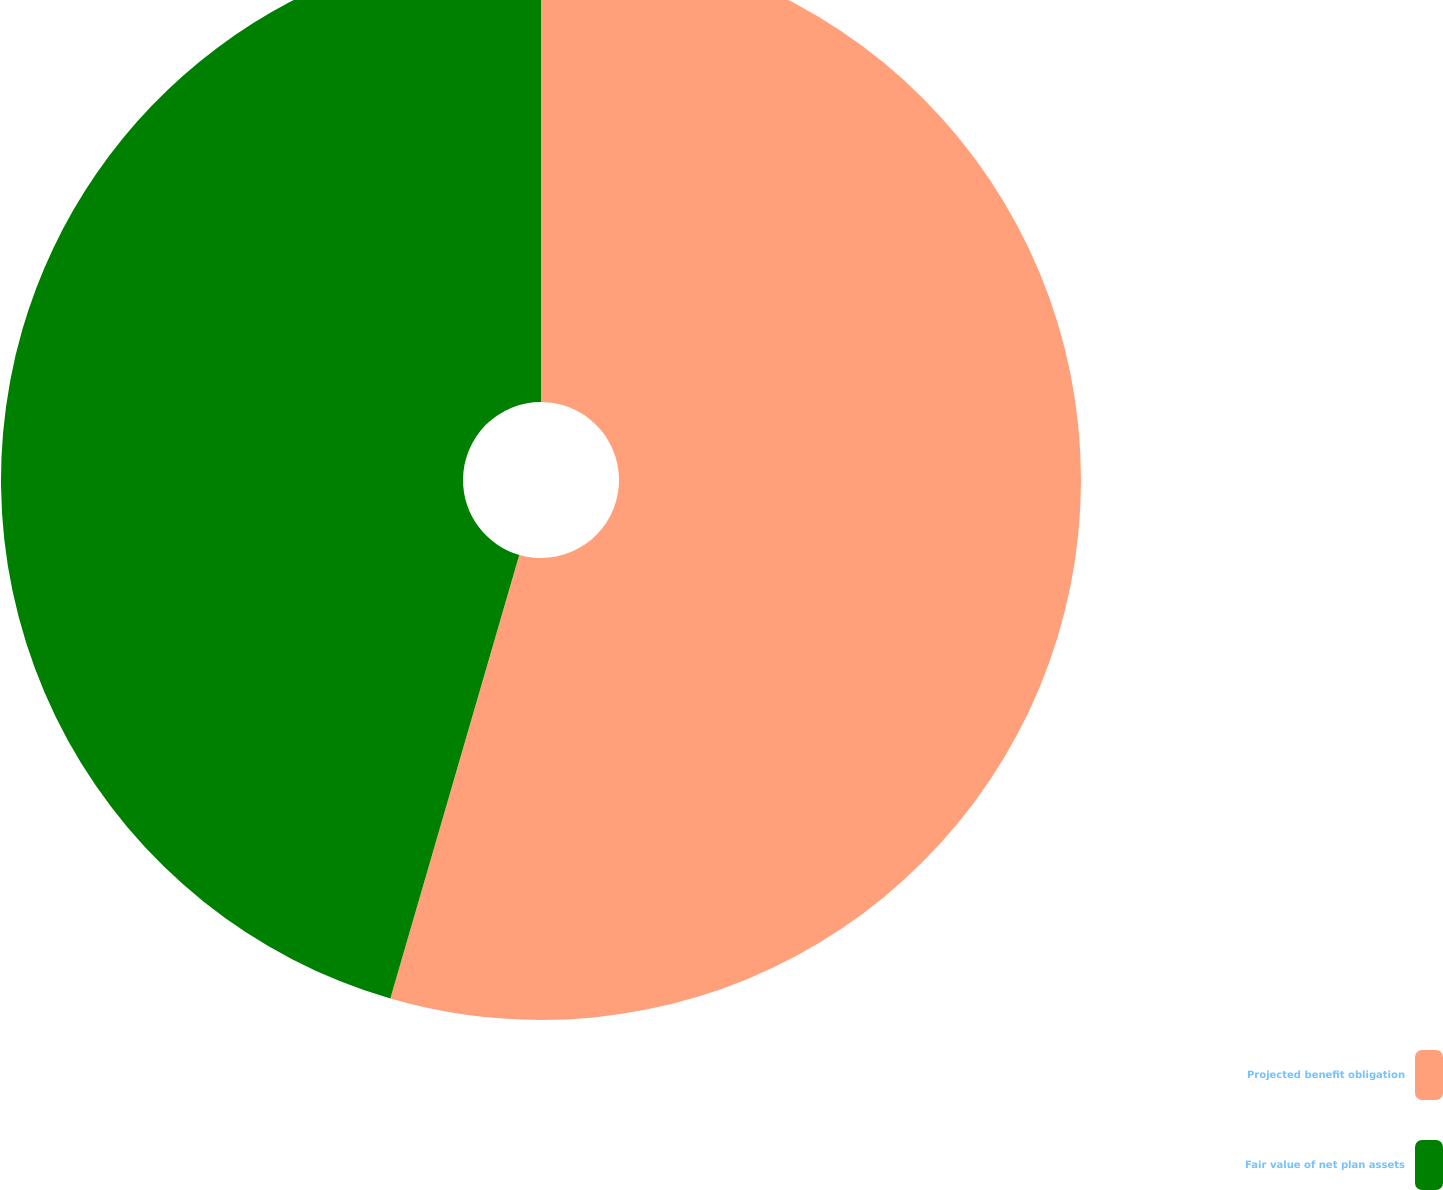<chart> <loc_0><loc_0><loc_500><loc_500><pie_chart><fcel>Projected benefit obligation<fcel>Fair value of net plan assets<nl><fcel>54.5%<fcel>45.5%<nl></chart> 